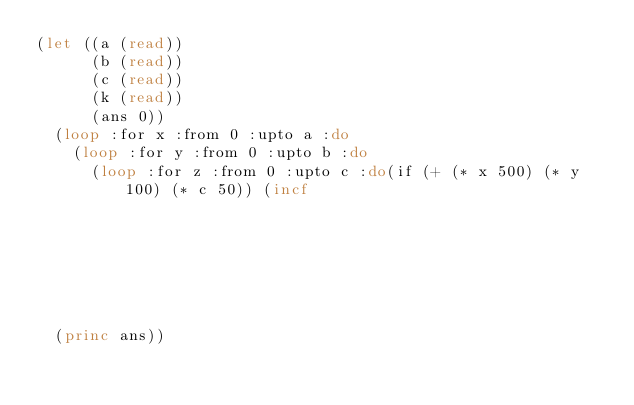<code> <loc_0><loc_0><loc_500><loc_500><_Lisp_>(let ((a (read))
      (b (read))
      (c (read))
      (k (read))
      (ans 0))
  (loop :for x :from 0 :upto a :do
    (loop :for y :from 0 :upto b :do
      (loop :for z :from 0 :upto c :do(if (+ (* x 500) (* y 100) (* c 50)) (incf
                                                                            ans)))))
  (princ ans))</code> 